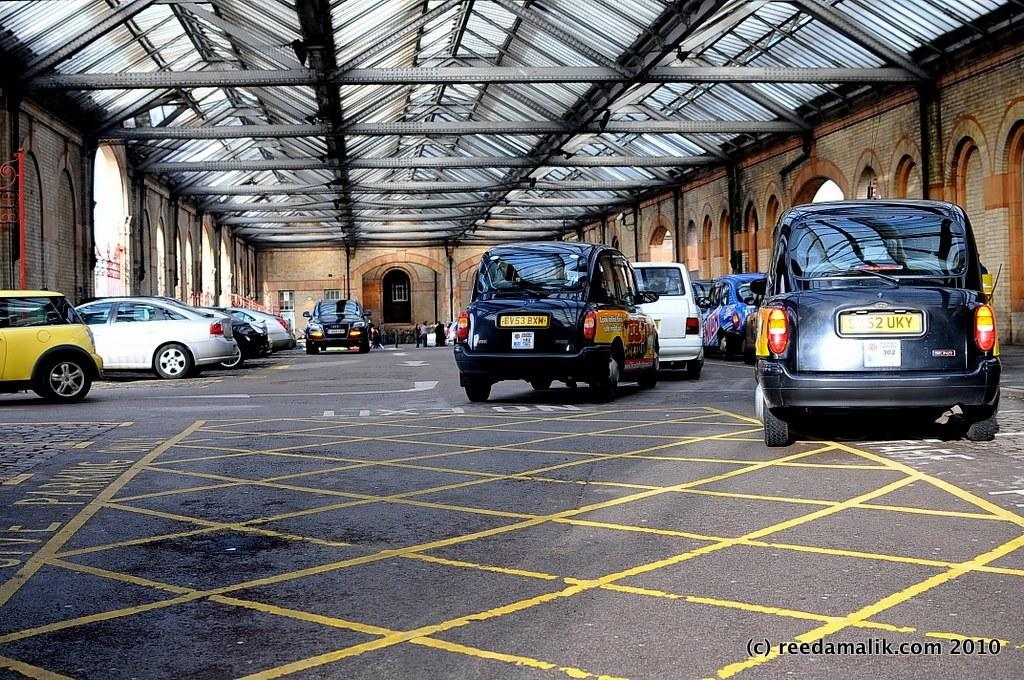<image>
Offer a succinct explanation of the picture presented. A parking garage with several cars, one of whose license plate is 8V53BXM 